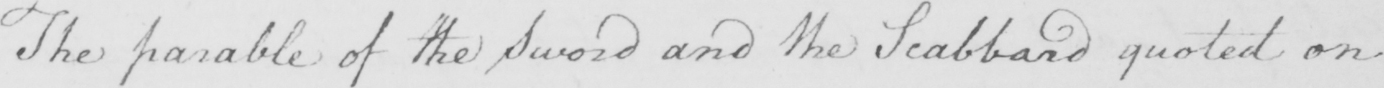What text is written in this handwritten line? The parable of the Sword and the Scabbard quoted on 